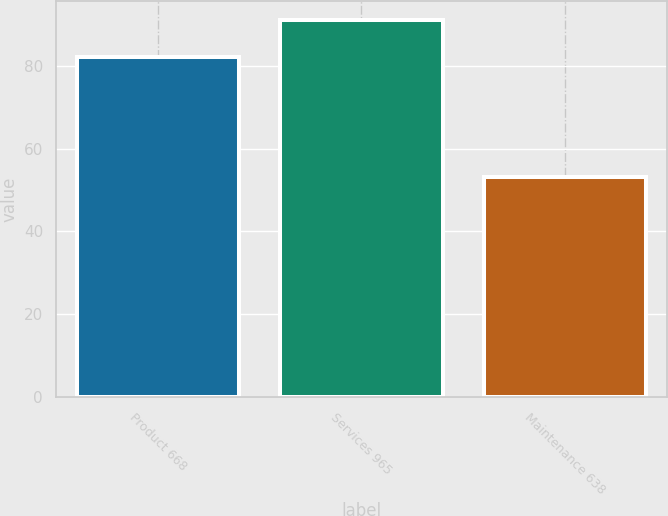<chart> <loc_0><loc_0><loc_500><loc_500><bar_chart><fcel>Product 668<fcel>Services 965<fcel>Maintenance 638<nl><fcel>82<fcel>91<fcel>53.1<nl></chart> 